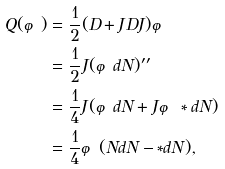Convert formula to latex. <formula><loc_0><loc_0><loc_500><loc_500>Q ( \varphi ) & = \frac { 1 } { 2 } ( D + J D J ) \varphi \\ & = \frac { 1 } { 2 } J ( \varphi d N ) ^ { \prime \prime } \\ & = \frac { 1 } { 4 } J ( \varphi d N + J \varphi * d N ) \\ & = \frac { 1 } { 4 } \varphi ( N d N - * d N ) ,</formula> 